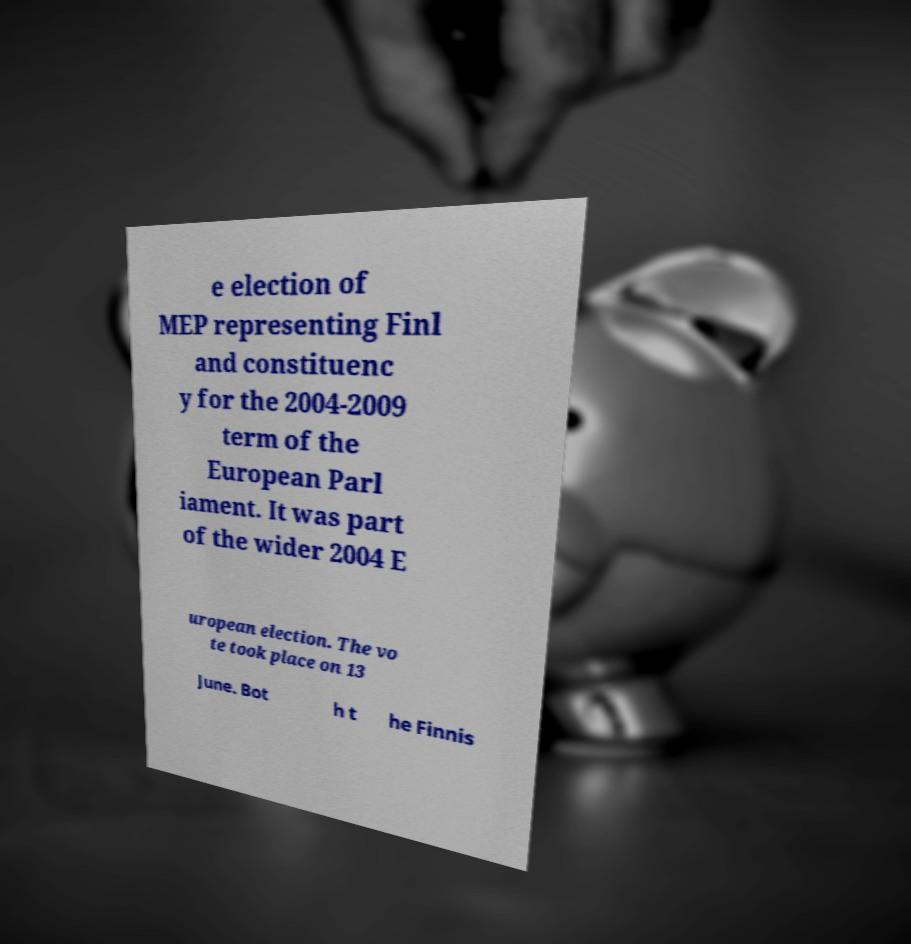Could you extract and type out the text from this image? e election of MEP representing Finl and constituenc y for the 2004-2009 term of the European Parl iament. It was part of the wider 2004 E uropean election. The vo te took place on 13 June. Bot h t he Finnis 